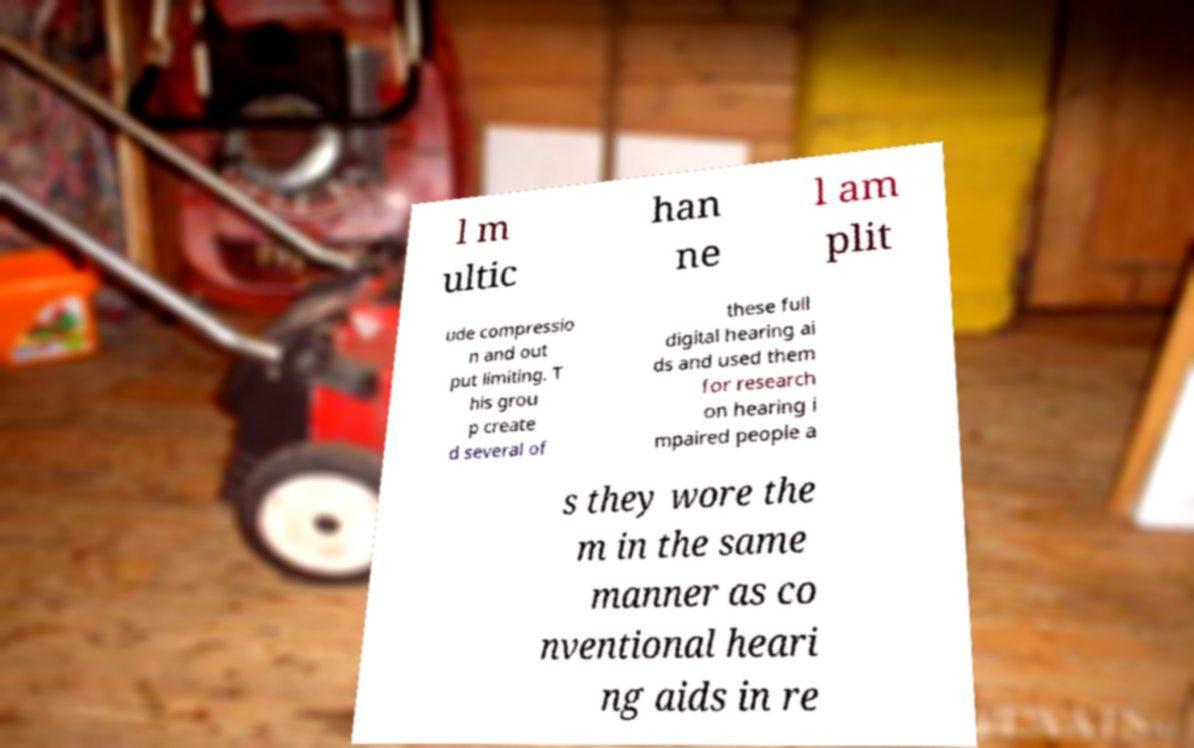Please read and relay the text visible in this image. What does it say? l m ultic han ne l am plit ude compressio n and out put limiting. T his grou p create d several of these full digital hearing ai ds and used them for research on hearing i mpaired people a s they wore the m in the same manner as co nventional heari ng aids in re 